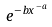Convert formula to latex. <formula><loc_0><loc_0><loc_500><loc_500>e ^ { - b x ^ { - a } }</formula> 